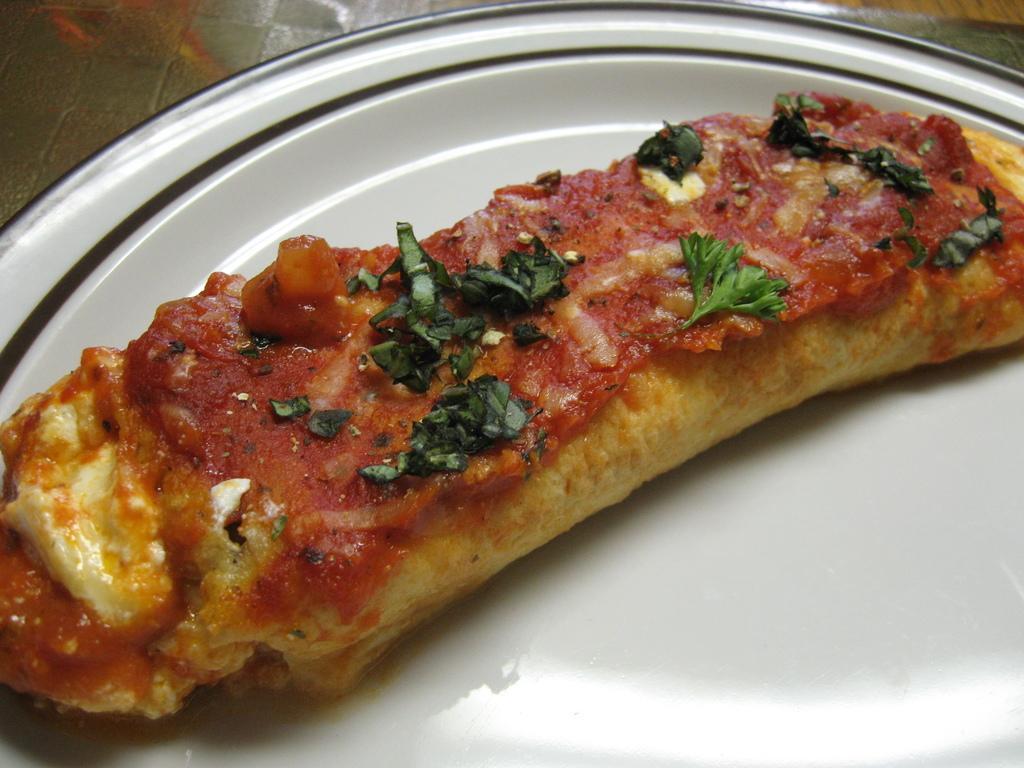In one or two sentences, can you explain what this image depicts? In this picture, we see a white plate containing a edible. In the left top, it is grey in color and it looks like the floor. 